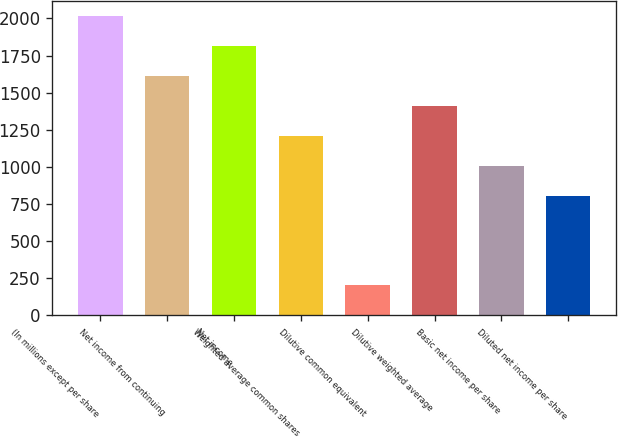Convert chart to OTSL. <chart><loc_0><loc_0><loc_500><loc_500><bar_chart><fcel>(In millions except per share<fcel>Net income from continuing<fcel>Net income<fcel>Weighted average common shares<fcel>Dilutive common equivalent<fcel>Dilutive weighted average<fcel>Basic net income per share<fcel>Diluted net income per share<nl><fcel>2016<fcel>1613.2<fcel>1814.6<fcel>1210.4<fcel>203.4<fcel>1411.8<fcel>1009<fcel>807.6<nl></chart> 